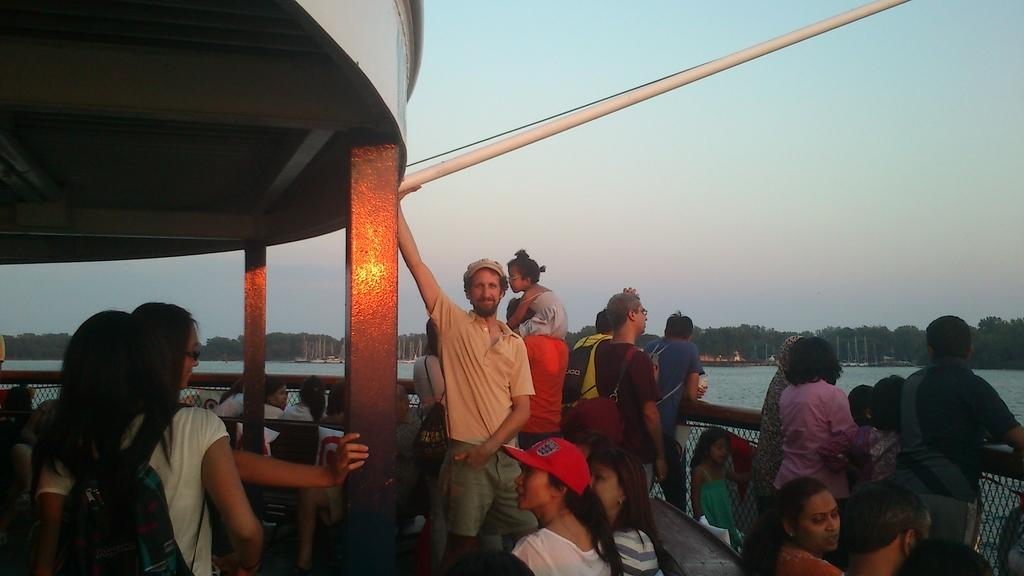How many people are in the group visible in the image? There is a group of people in the image, but the exact number cannot be determined from the provided facts. What structures can be seen in the image? There are poles and railing visible in the image. What can be seen in the background of the image? Trees and the sky are visible in the background of the image. What type of watercraft is visible in the image? There are objects that look like boats on the water. What color is the owl perched on the railing in the image? There is no owl present in the image. What is the rate at which the boats are moving in the image? The rate at which the boats are moving cannot be determined from the provided facts, as there is no information about their speed or motion. 